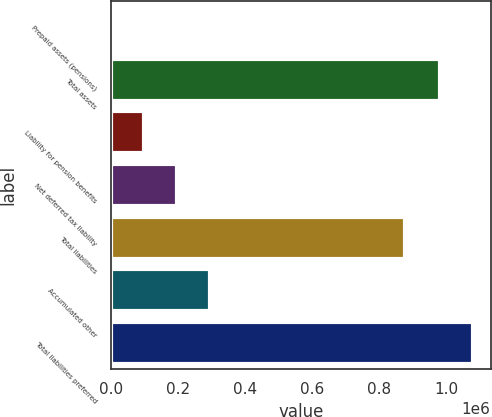<chart> <loc_0><loc_0><loc_500><loc_500><bar_chart><fcel>Prepaid assets (pensions)<fcel>Total assets<fcel>Liability for pension benefits<fcel>Net deferred tax liability<fcel>Total liabilities<fcel>Accumulated other<fcel>Total liabilities preferred<nl><fcel>550<fcel>979952<fcel>98490.2<fcel>196430<fcel>877552<fcel>294371<fcel>1.07789e+06<nl></chart> 